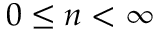Convert formula to latex. <formula><loc_0><loc_0><loc_500><loc_500>0 \leq n < \infty</formula> 